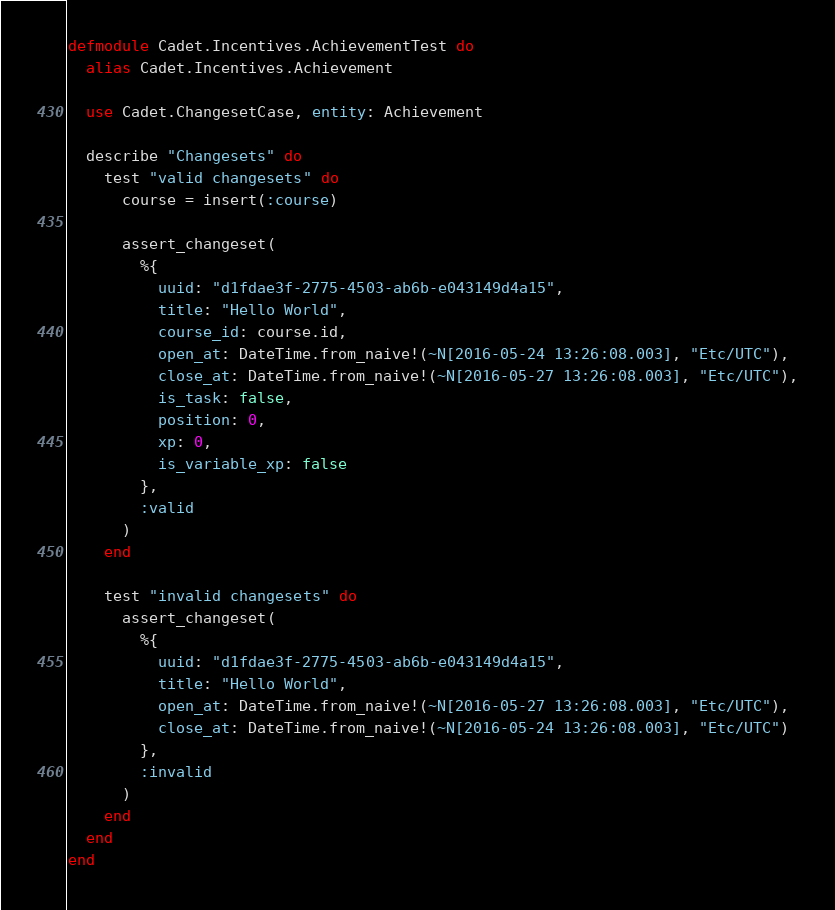Convert code to text. <code><loc_0><loc_0><loc_500><loc_500><_Elixir_>defmodule Cadet.Incentives.AchievementTest do
  alias Cadet.Incentives.Achievement

  use Cadet.ChangesetCase, entity: Achievement

  describe "Changesets" do
    test "valid changesets" do
      course = insert(:course)

      assert_changeset(
        %{
          uuid: "d1fdae3f-2775-4503-ab6b-e043149d4a15",
          title: "Hello World",
          course_id: course.id,
          open_at: DateTime.from_naive!(~N[2016-05-24 13:26:08.003], "Etc/UTC"),
          close_at: DateTime.from_naive!(~N[2016-05-27 13:26:08.003], "Etc/UTC"),
          is_task: false,
          position: 0,
          xp: 0,
          is_variable_xp: false
        },
        :valid
      )
    end

    test "invalid changesets" do
      assert_changeset(
        %{
          uuid: "d1fdae3f-2775-4503-ab6b-e043149d4a15",
          title: "Hello World",
          open_at: DateTime.from_naive!(~N[2016-05-27 13:26:08.003], "Etc/UTC"),
          close_at: DateTime.from_naive!(~N[2016-05-24 13:26:08.003], "Etc/UTC")
        },
        :invalid
      )
    end
  end
end
</code> 